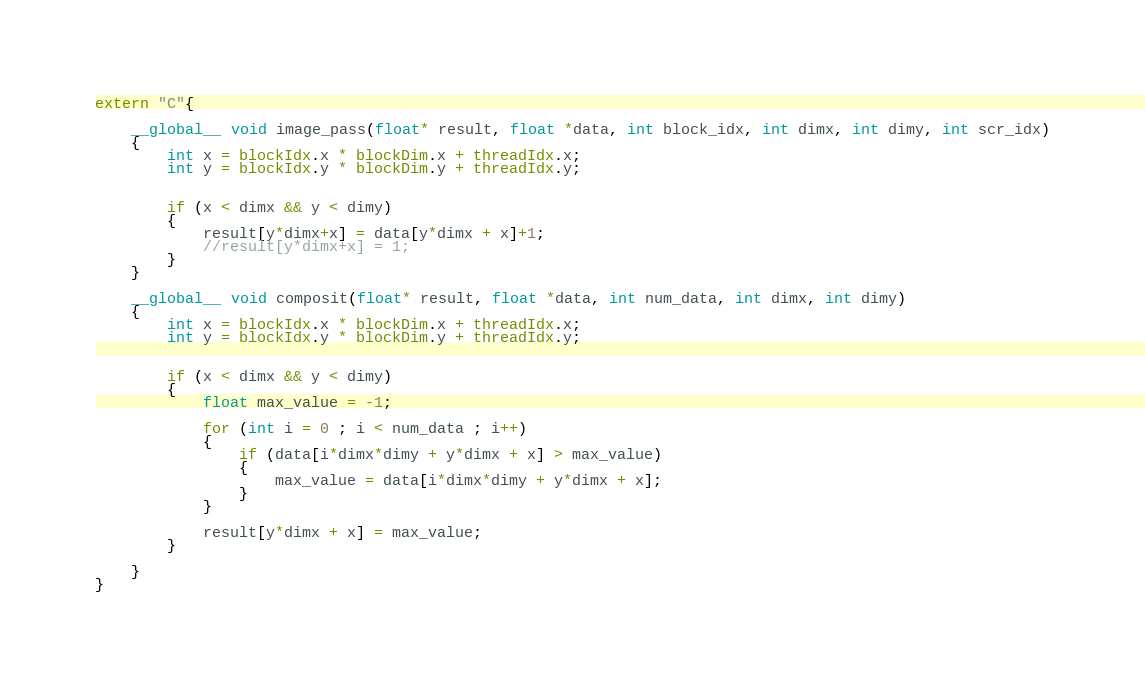<code> <loc_0><loc_0><loc_500><loc_500><_Cuda_>
extern "C"{

    __global__ void image_pass(float* result, float *data, int block_idx, int dimx, int dimy, int scr_idx)
    {
	    int x = blockIdx.x * blockDim.x + threadIdx.x;
	    int y = blockIdx.y * blockDim.y + threadIdx.y;


        if (x < dimx && y < dimy)
        {
            result[y*dimx+x] = data[y*dimx + x]+1;
            //result[y*dimx+x] = 1;
        }
    }

    __global__ void composit(float* result, float *data, int num_data, int dimx, int dimy)
    {
	    int x = blockIdx.x * blockDim.x + threadIdx.x;
	    int y = blockIdx.y * blockDim.y + threadIdx.y;


        if (x < dimx && y < dimy)
        {
            float max_value = -1;
            
            for (int i = 0 ; i < num_data ; i++)
            {
                if (data[i*dimx*dimy + y*dimx + x] > max_value)
                {
                    max_value = data[i*dimx*dimy + y*dimx + x];
                }
            }
           
            result[y*dimx + x] = max_value;   
        }
    
    }
}
</code> 